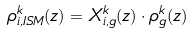<formula> <loc_0><loc_0><loc_500><loc_500>\rho _ { i , I S M } ^ { k } ( z ) = X _ { i , g } ^ { k } ( z ) \cdot \rho _ { g } ^ { k } ( z )</formula> 